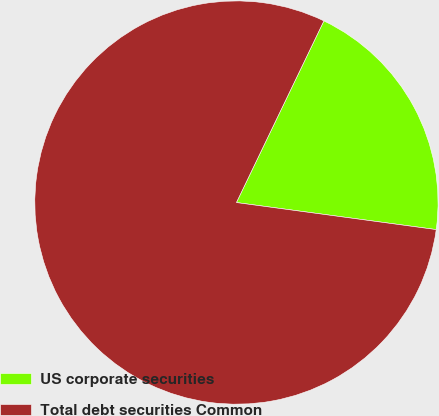Convert chart. <chart><loc_0><loc_0><loc_500><loc_500><pie_chart><fcel>US corporate securities<fcel>Total debt securities Common<nl><fcel>20.0%<fcel>80.0%<nl></chart> 